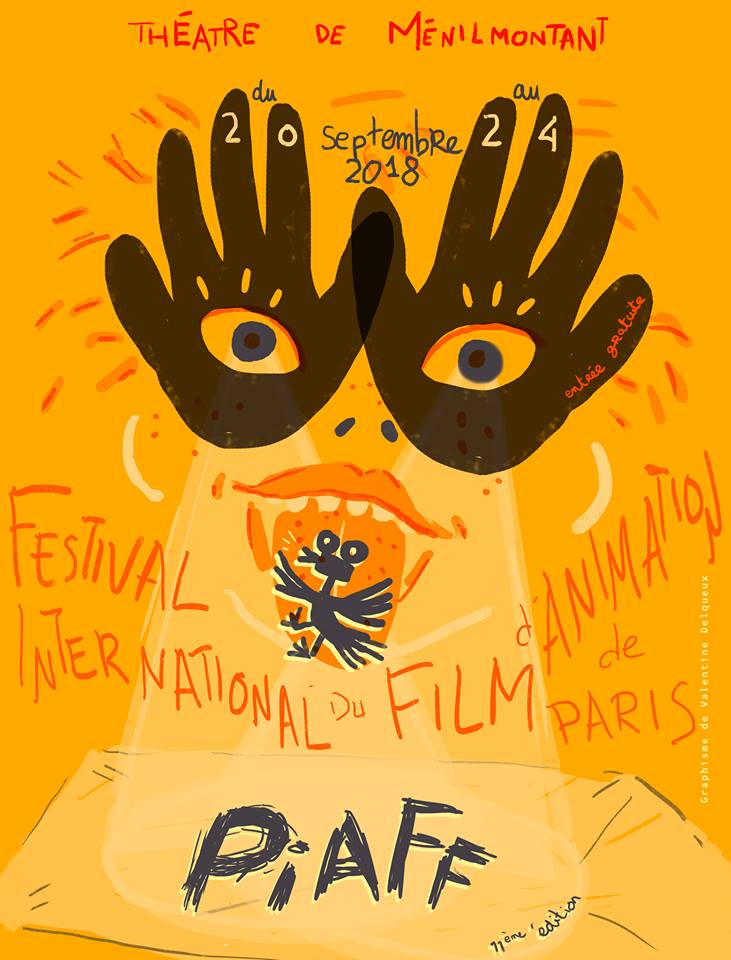If this poster came to life, what do you imagine happening next? If this poster came to life, it would transform into a lively animation scene. The large hands with eyes might begin to move, waving and making gestures as though they are performing. The small character in the center could come to life, dancing and interacting with the audience, inviting them to the festival with joyous and playful antics. The vibrant colors and expressive typography would animate, perhaps with the letters of 'P·A·F' bouncing around energetically, creating a dynamic and entertaining spectacle that brings the festival's spirit directly to life for the viewers. 